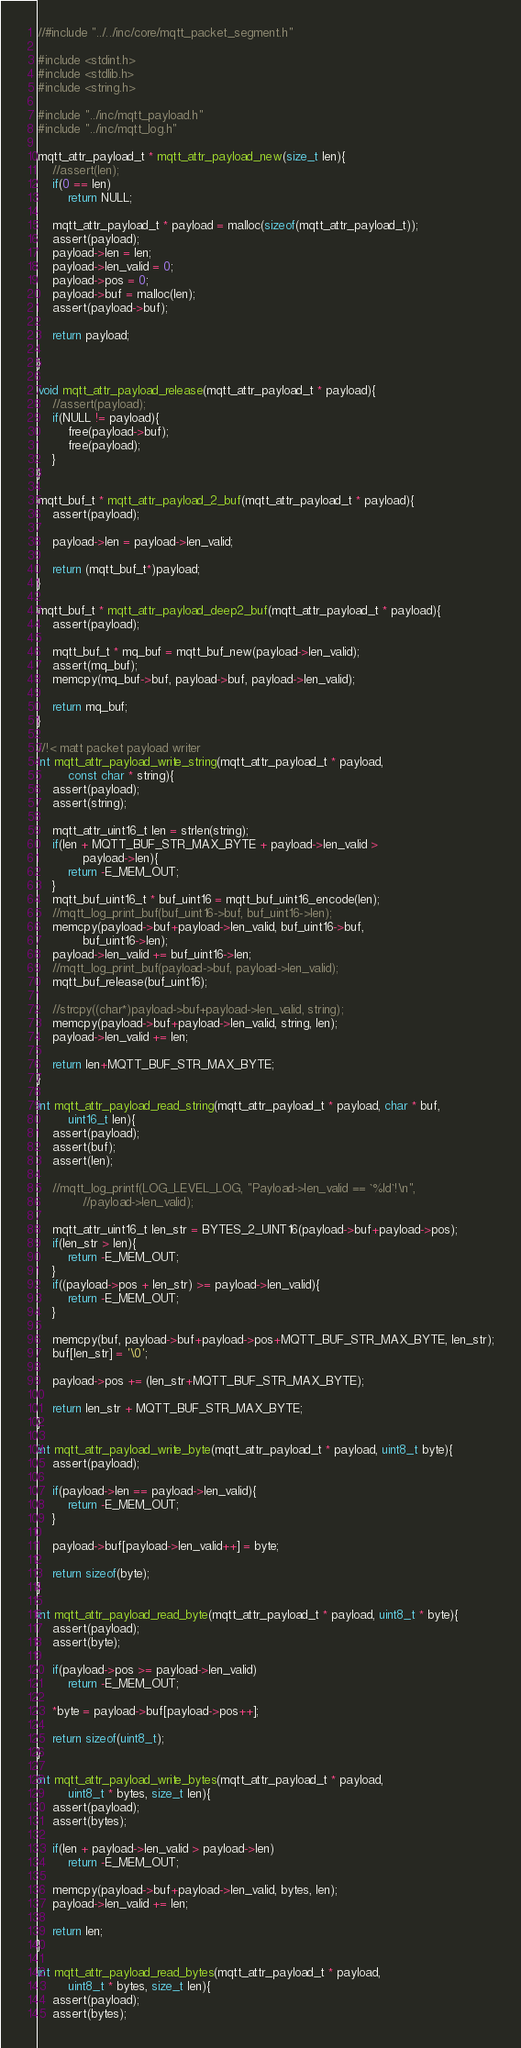Convert code to text. <code><loc_0><loc_0><loc_500><loc_500><_C_>//#include "../../inc/core/mqtt_packet_segment.h"

#include <stdint.h>
#include <stdlib.h>
#include <string.h>

#include "../inc/mqtt_payload.h"
#include "../inc/mqtt_log.h"

mqtt_attr_payload_t * mqtt_attr_payload_new(size_t len){
	//assert(len);
	if(0 == len)
		return NULL;

	mqtt_attr_payload_t * payload = malloc(sizeof(mqtt_attr_payload_t));
	assert(payload);
	payload->len = len;
	payload->len_valid = 0;
	payload->pos = 0;
	payload->buf = malloc(len);
	assert(payload->buf);
	
	return payload;
	
}

void mqtt_attr_payload_release(mqtt_attr_payload_t * payload){
	//assert(payload);
	if(NULL != payload){
		free(payload->buf);
		free(payload);
	}
}

mqtt_buf_t * mqtt_attr_payload_2_buf(mqtt_attr_payload_t * payload){
	assert(payload);

	payload->len = payload->len_valid;

	return (mqtt_buf_t*)payload;
}

mqtt_buf_t * mqtt_attr_payload_deep2_buf(mqtt_attr_payload_t * payload){
	assert(payload);

	mqtt_buf_t * mq_buf = mqtt_buf_new(payload->len_valid);
	assert(mq_buf);
	memcpy(mq_buf->buf, payload->buf, payload->len_valid);

	return mq_buf;
}

//!< matt packet payload writer
int mqtt_attr_payload_write_string(mqtt_attr_payload_t * payload, 
		const char * string){
	assert(payload);
	assert(string);

	mqtt_attr_uint16_t len = strlen(string);
	if(len + MQTT_BUF_STR_MAX_BYTE + payload->len_valid > 
			payload->len){
		return -E_MEM_OUT;
	}
	mqtt_buf_uint16_t * buf_uint16 = mqtt_buf_uint16_encode(len);
	//mqtt_log_print_buf(buf_uint16->buf, buf_uint16->len);
	memcpy(payload->buf+payload->len_valid, buf_uint16->buf, 
			buf_uint16->len);
	payload->len_valid += buf_uint16->len;
	//mqtt_log_print_buf(payload->buf, payload->len_valid);
	mqtt_buf_release(buf_uint16);

	//strcpy((char*)payload->buf+payload->len_valid, string);
	memcpy(payload->buf+payload->len_valid, string, len);
	payload->len_valid += len;

	return len+MQTT_BUF_STR_MAX_BYTE;
}

int mqtt_attr_payload_read_string(mqtt_attr_payload_t * payload, char * buf, 
		uint16_t len){
	assert(payload);
	assert(buf);
	assert(len);

	//mqtt_log_printf(LOG_LEVEL_LOG, "Payload->len_valid == `%ld`!\n", 
			//payload->len_valid);

	mqtt_attr_uint16_t len_str = BYTES_2_UINT16(payload->buf+payload->pos);
	if(len_str > len){
		return -E_MEM_OUT;
	}
	if((payload->pos + len_str) >= payload->len_valid){
		return -E_MEM_OUT;
	}

	memcpy(buf, payload->buf+payload->pos+MQTT_BUF_STR_MAX_BYTE, len_str);
	buf[len_str] = '\0';

	payload->pos += (len_str+MQTT_BUF_STR_MAX_BYTE);

	return len_str + MQTT_BUF_STR_MAX_BYTE;
}

int mqtt_attr_payload_write_byte(mqtt_attr_payload_t * payload, uint8_t byte){
	assert(payload);

	if(payload->len == payload->len_valid){
		return -E_MEM_OUT;
	}

	payload->buf[payload->len_valid++] = byte;
	
	return sizeof(byte);
}

int mqtt_attr_payload_read_byte(mqtt_attr_payload_t * payload, uint8_t * byte){
	assert(payload);
	assert(byte);

	if(payload->pos >= payload->len_valid)
		return -E_MEM_OUT;

	*byte = payload->buf[payload->pos++];

	return sizeof(uint8_t);
}

int mqtt_attr_payload_write_bytes(mqtt_attr_payload_t * payload, 
		uint8_t * bytes, size_t len){
	assert(payload);
	assert(bytes);

	if(len + payload->len_valid > payload->len)
		return -E_MEM_OUT;

	memcpy(payload->buf+payload->len_valid, bytes, len);
	payload->len_valid += len;

	return len;
}

int mqtt_attr_payload_read_bytes(mqtt_attr_payload_t * payload, 
		uint8_t * bytes, size_t len){
	assert(payload);
	assert(bytes);
</code> 